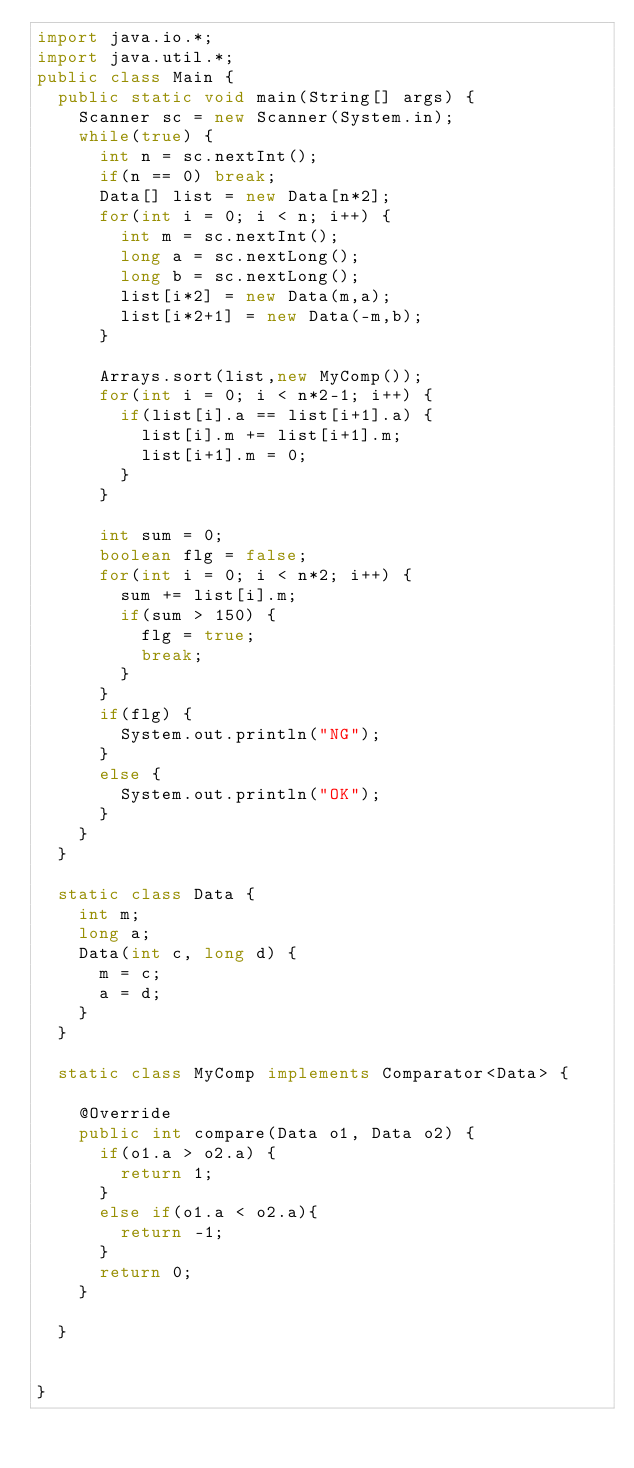<code> <loc_0><loc_0><loc_500><loc_500><_Java_>import java.io.*;
import java.util.*;
public class Main {
	public static void main(String[] args) {
		Scanner sc = new Scanner(System.in);
		while(true) {
			int n = sc.nextInt();
			if(n == 0) break;
			Data[] list = new Data[n*2];
			for(int i = 0; i < n; i++) {
				int m = sc.nextInt();
				long a = sc.nextLong();
				long b = sc.nextLong();
				list[i*2] = new Data(m,a);
				list[i*2+1] = new Data(-m,b);
			}
			
			Arrays.sort(list,new MyComp());
			for(int i = 0; i < n*2-1; i++) {
				if(list[i].a == list[i+1].a) {
					list[i].m += list[i+1].m;
					list[i+1].m = 0;
				}
			}
			
			int sum = 0;
			boolean flg = false;
			for(int i = 0; i < n*2; i++) {
				sum += list[i].m;
				if(sum > 150) {
					flg = true;
					break;
				}
			}
			if(flg) {
				System.out.println("NG");
			}
			else {
				System.out.println("OK");
			}
		}
	}
	
	static class Data {
		int m;
		long a;
		Data(int c, long d) {
			m = c;
			a = d;
		}
	}
	
	static class MyComp implements Comparator<Data> {

		@Override
		public int compare(Data o1, Data o2) {
			if(o1.a > o2.a) {
				return 1;
			}
			else if(o1.a < o2.a){
				return -1;
			}
			return 0;
		}
		
	}
	
		
}</code> 